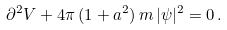<formula> <loc_0><loc_0><loc_500><loc_500>\partial ^ { 2 } V + 4 \pi \, ( 1 + a ^ { 2 } ) \, m \, | \psi | ^ { 2 } = 0 \, .</formula> 